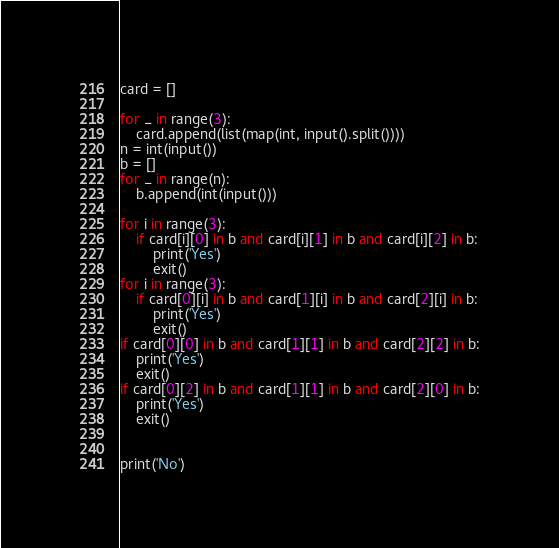<code> <loc_0><loc_0><loc_500><loc_500><_Python_>card = []

for _ in range(3):
    card.append(list(map(int, input().split())))
n = int(input())
b = []
for _ in range(n):
    b.append(int(input()))

for i in range(3):
    if card[i][0] in b and card[i][1] in b and card[i][2] in b:
        print('Yes')
        exit()
for i in range(3):
    if card[0][i] in b and card[1][i] in b and card[2][i] in b:
        print('Yes')
        exit()
if card[0][0] in b and card[1][1] in b and card[2][2] in b:
    print('Yes')
    exit()
if card[0][2] in b and card[1][1] in b and card[2][0] in b:
    print('Yes')
    exit()


print('No')</code> 